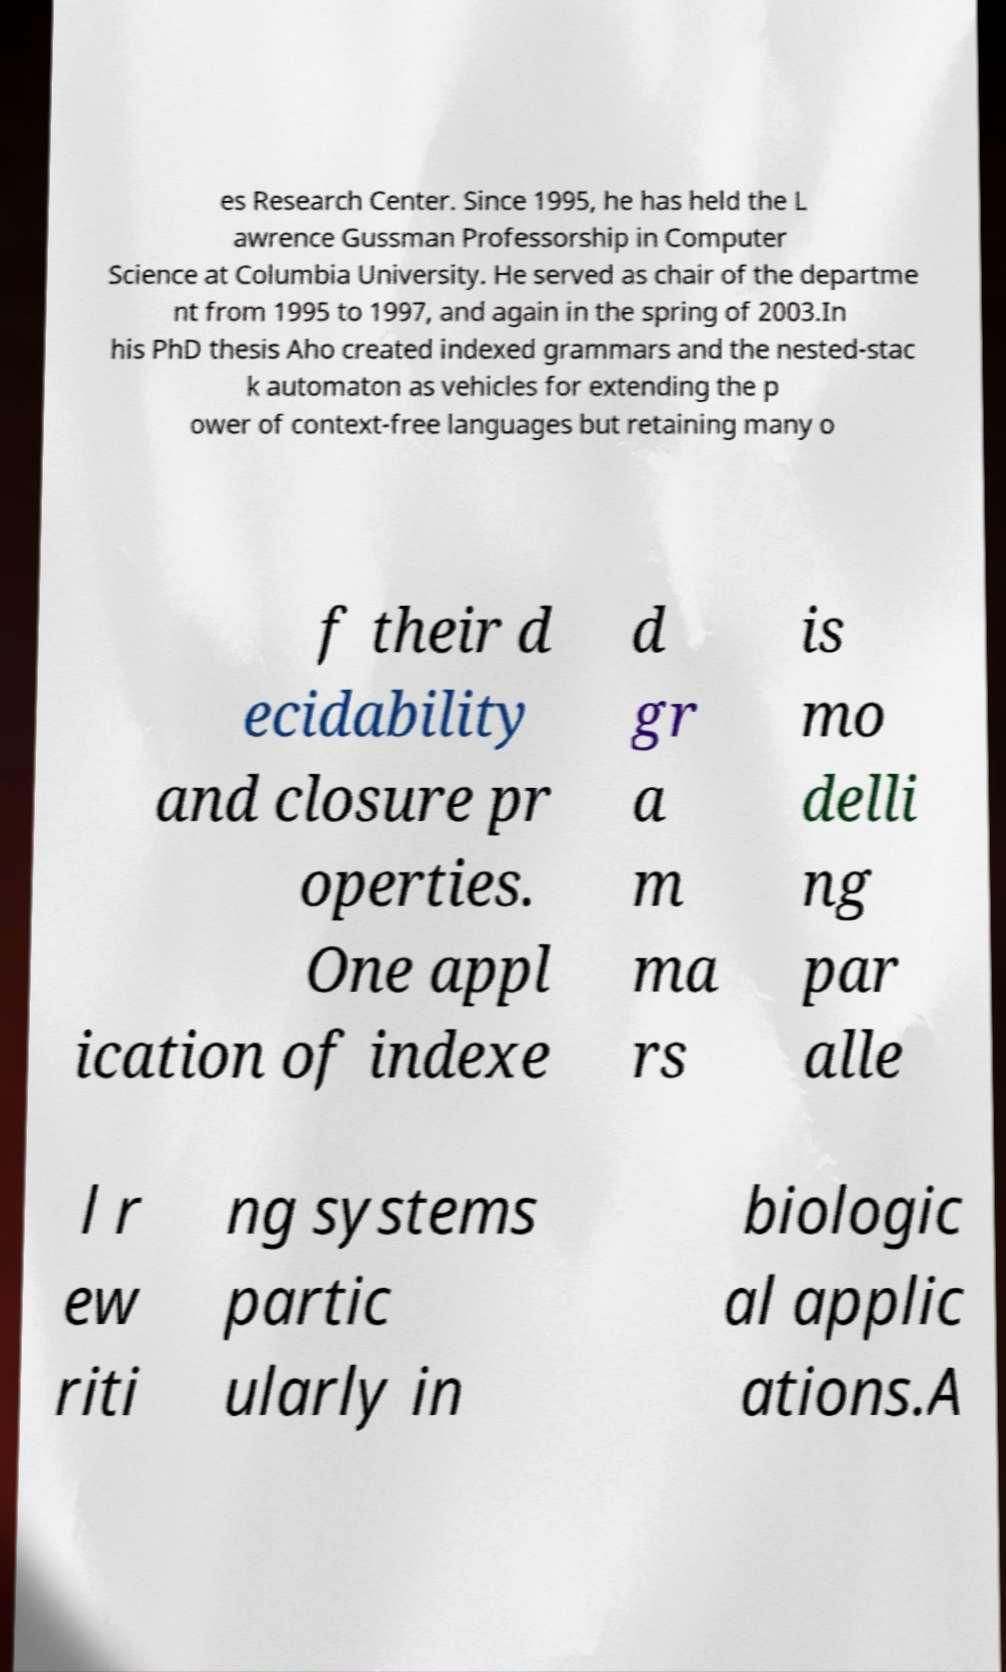Could you extract and type out the text from this image? es Research Center. Since 1995, he has held the L awrence Gussman Professorship in Computer Science at Columbia University. He served as chair of the departme nt from 1995 to 1997, and again in the spring of 2003.In his PhD thesis Aho created indexed grammars and the nested-stac k automaton as vehicles for extending the p ower of context-free languages but retaining many o f their d ecidability and closure pr operties. One appl ication of indexe d gr a m ma rs is mo delli ng par alle l r ew riti ng systems partic ularly in biologic al applic ations.A 